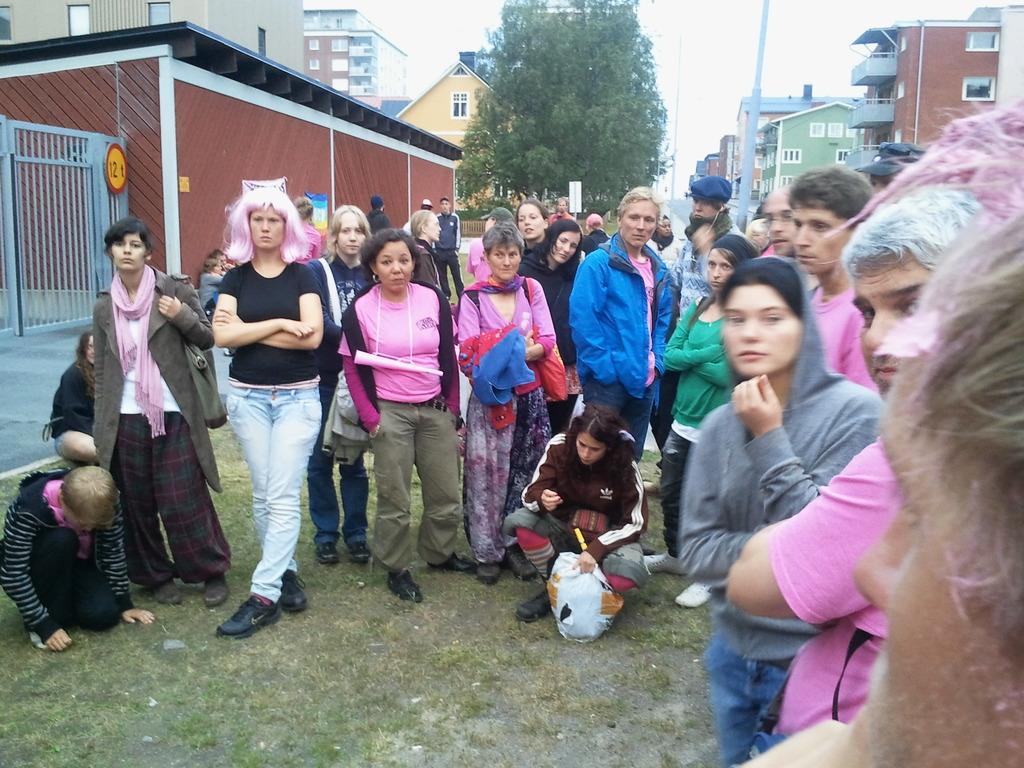Could you give a brief overview of what you see in this image? In this image we can see a group of people standing on the grass field. Two women are wearing bags. In the foreground of the image we can see a bag placed on the ground. On the left side of the image we can see a woman sitting on the ground and a gate. In the background, we can see a group of buildings with windows, railings and a pole. At the top of the image we can see tree and the sky. 